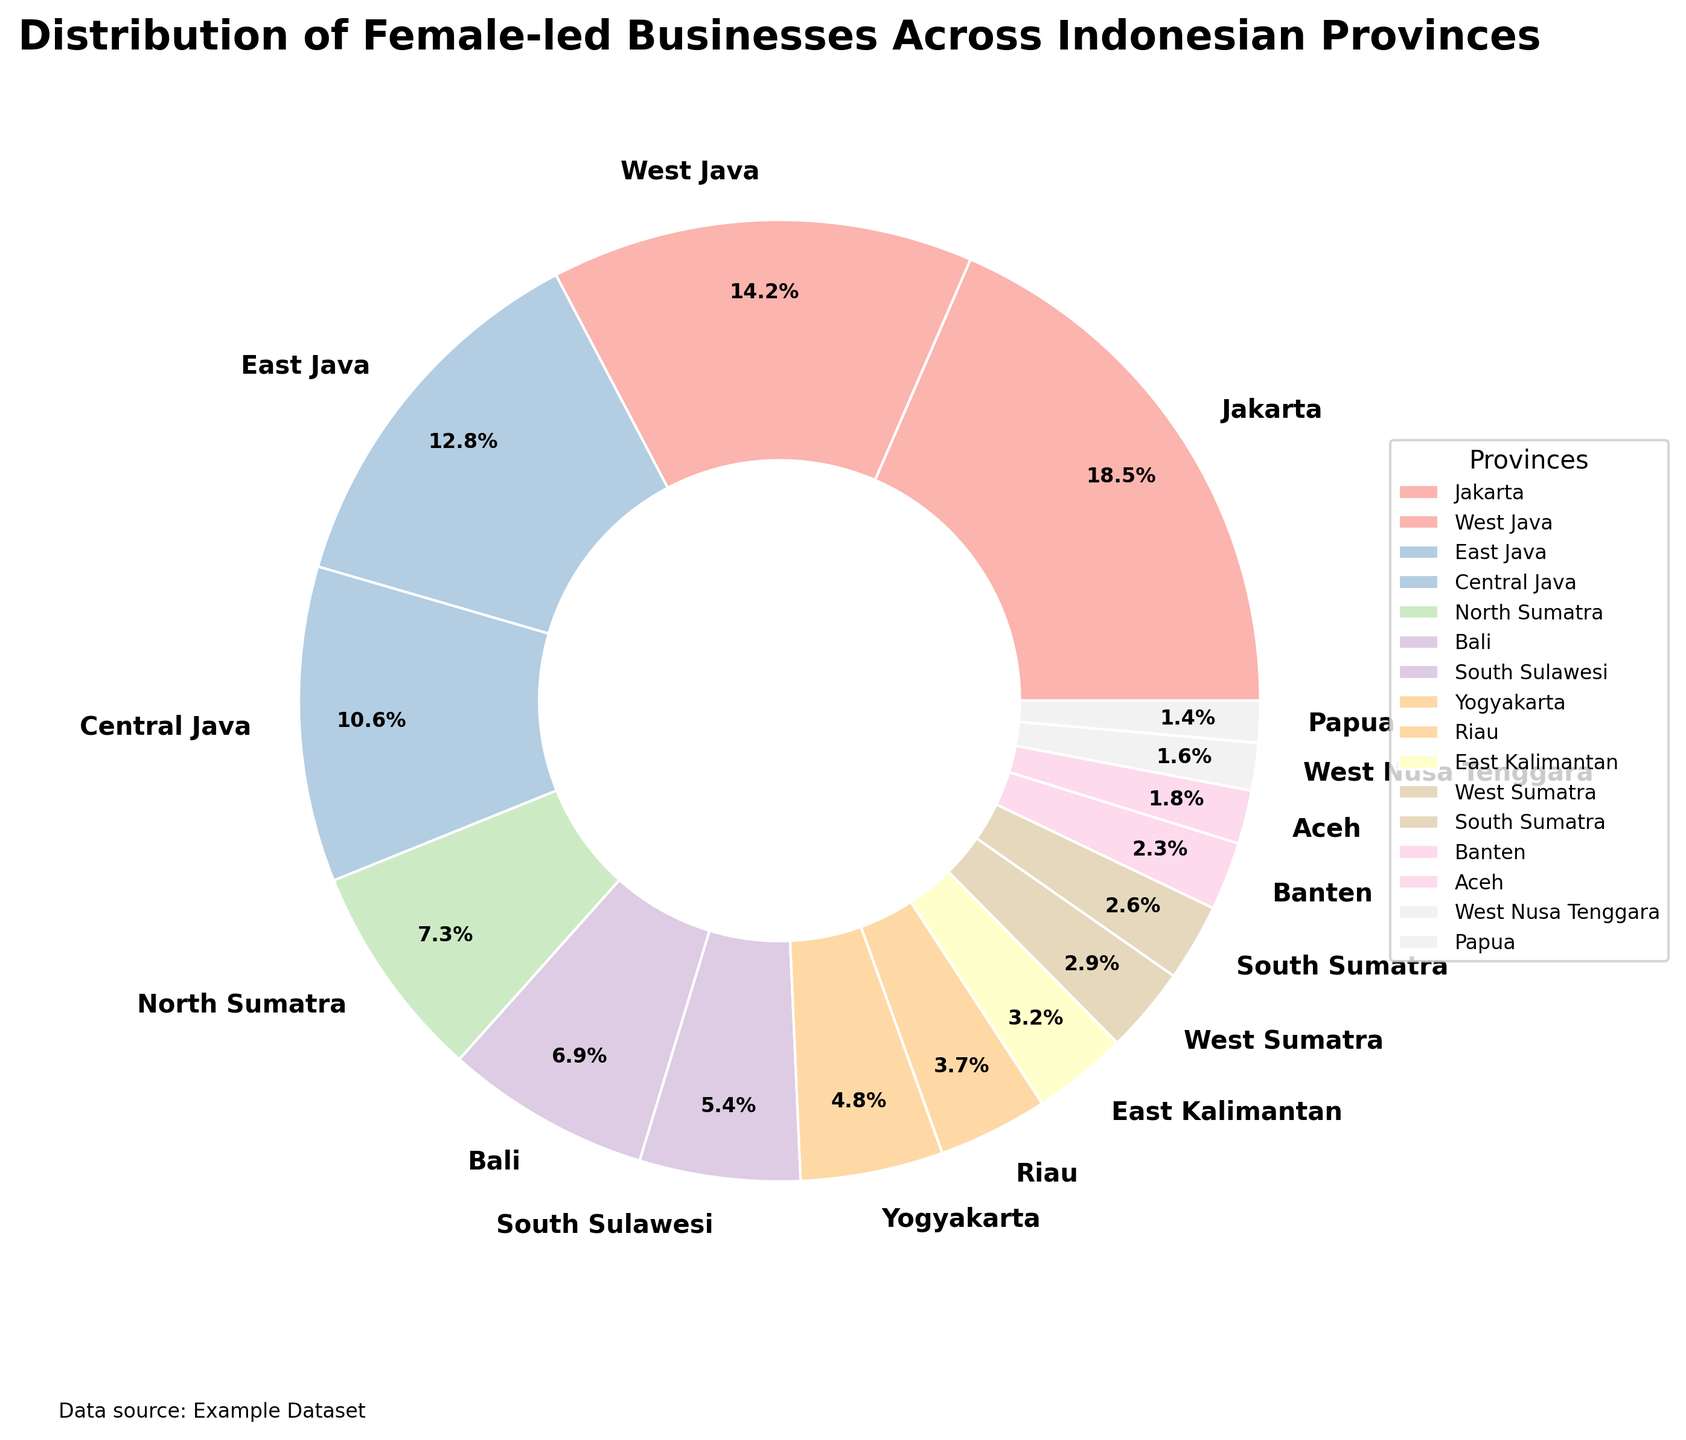Which province has the highest percentage of female-led businesses? The pie chart shows the percentages clearly. Jakarta has the largest pie slice, labeled with 18.5%.
Answer: Jakarta Which two provinces together account for more than 30% of female-led businesses? By adding the percentages, the provinces Jakarta (18.5%) and West Java (14.2%) together total 32.7%, which is more than 30%.
Answer: Jakarta and West Java What is the difference in the percentage of female-led businesses between Jakarta and Bali? Jakarta has 18.5% and Bali has 6.9%. Subtracting these values gives a difference of 11.6%.
Answer: 11.6% Which province has a percentage closest to the average percentage of all provinces? First, calculate the average by summing all percentages and dividing by the number of provinces (sum = 100%) resulting in an average of 6.25%. Then check which province's percentage is closest to this value; Bali, with 6.9%, is closest.
Answer: Bali Is the percentage of female-led businesses in Central Java higher or lower than that of East Java? Comparing the two percentages, Central Java has 10.6% while East Java has 12.8%. Central Java's percentage is lower.
Answer: Lower How many provinces have a percentage less than 5% of female-led businesses? The pie chart indicates percentages for each province. Counting those below 5% (8 provinces: Yogyakarta, Riau, East Kalimantan, West Sumatra, South Sumatra, Banten, Aceh, West Nusa Tenggara, and Papua) gives us the answer.
Answer: 9 If Jakarta's percentage was reduced by 3%, would it still have the highest percentage of female-led businesses? Reducing Jakarta’s 18.5% by 3% results in 15.5%. The next highest percentage is West Java with 14.2%. Yes, 15.5% is still higher than 14.2%.
Answer: Yes Which province has a greater percentage of female-led businesses, East Kalimantan or West Sumatra? Looking at the pie chart, East Kalimantan has 3.2% while West Sumatra has 2.9%. East Kalimantan's percentage is greater.
Answer: East Kalimantan What is the total percentage of female-led businesses in the four provinces with the smallest percentages? Summing up the smallest percentages: South Sumatra (2.6%) + Banten (2.3%) + Aceh (1.8%) + West Nusa Tenggara (1.6%) + Papua (1.4%) equals 9.7%.
Answer: 9.7% 